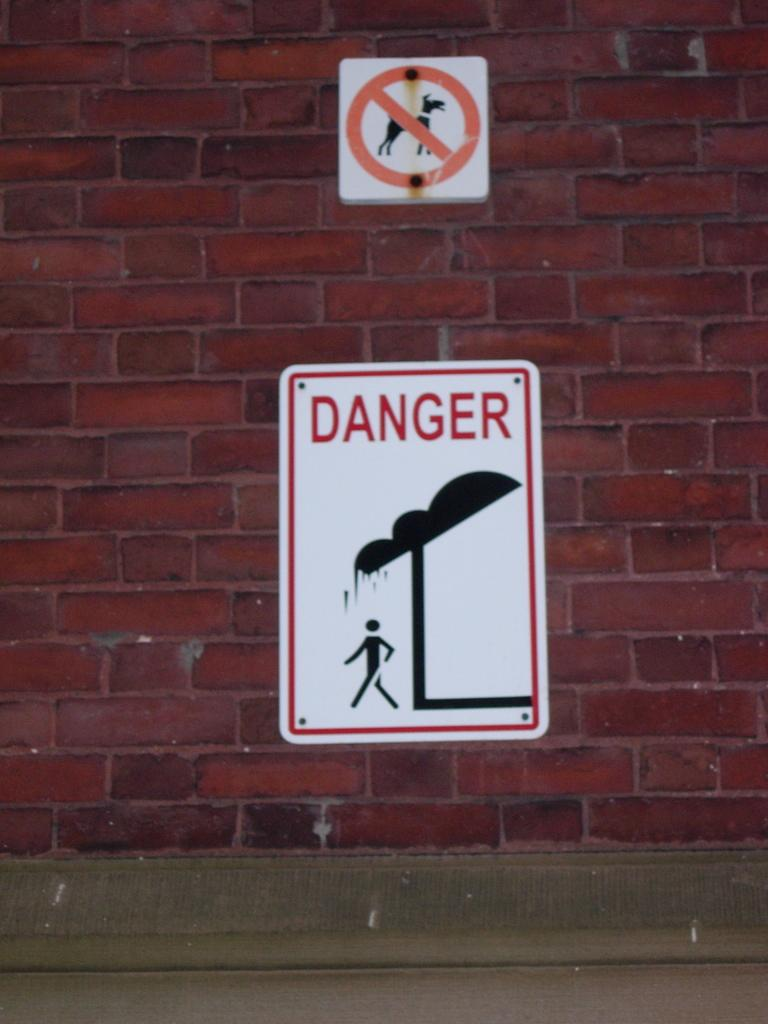Provide a one-sentence caption for the provided image. Two street signs, one say no dogs, the other says danger. 